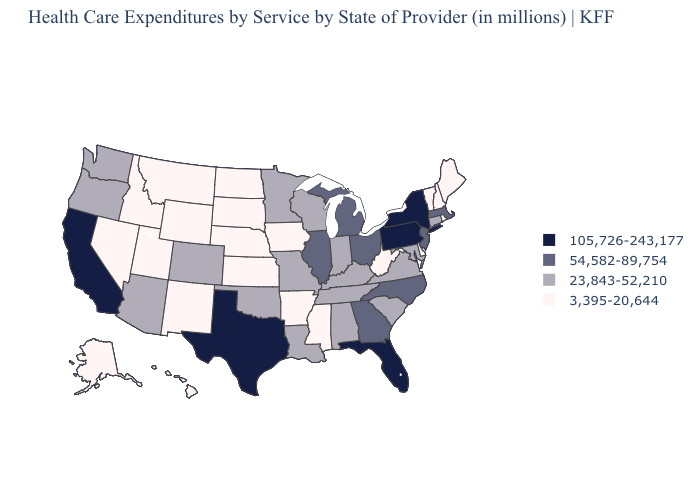Among the states that border Connecticut , does Rhode Island have the highest value?
Answer briefly. No. Which states have the highest value in the USA?
Keep it brief. California, Florida, New York, Pennsylvania, Texas. Name the states that have a value in the range 105,726-243,177?
Answer briefly. California, Florida, New York, Pennsylvania, Texas. Among the states that border Colorado , does Utah have the lowest value?
Be succinct. Yes. What is the value of Alabama?
Concise answer only. 23,843-52,210. Does Vermont have the lowest value in the Northeast?
Concise answer only. Yes. What is the value of Florida?
Quick response, please. 105,726-243,177. Does California have the highest value in the West?
Be succinct. Yes. What is the value of Tennessee?
Write a very short answer. 23,843-52,210. What is the value of Nevada?
Give a very brief answer. 3,395-20,644. Name the states that have a value in the range 54,582-89,754?
Answer briefly. Georgia, Illinois, Massachusetts, Michigan, New Jersey, North Carolina, Ohio. Does Montana have the lowest value in the West?
Write a very short answer. Yes. Name the states that have a value in the range 3,395-20,644?
Short answer required. Alaska, Arkansas, Delaware, Hawaii, Idaho, Iowa, Kansas, Maine, Mississippi, Montana, Nebraska, Nevada, New Hampshire, New Mexico, North Dakota, Rhode Island, South Dakota, Utah, Vermont, West Virginia, Wyoming. What is the value of Pennsylvania?
Be succinct. 105,726-243,177. Among the states that border Indiana , does Illinois have the highest value?
Write a very short answer. Yes. 